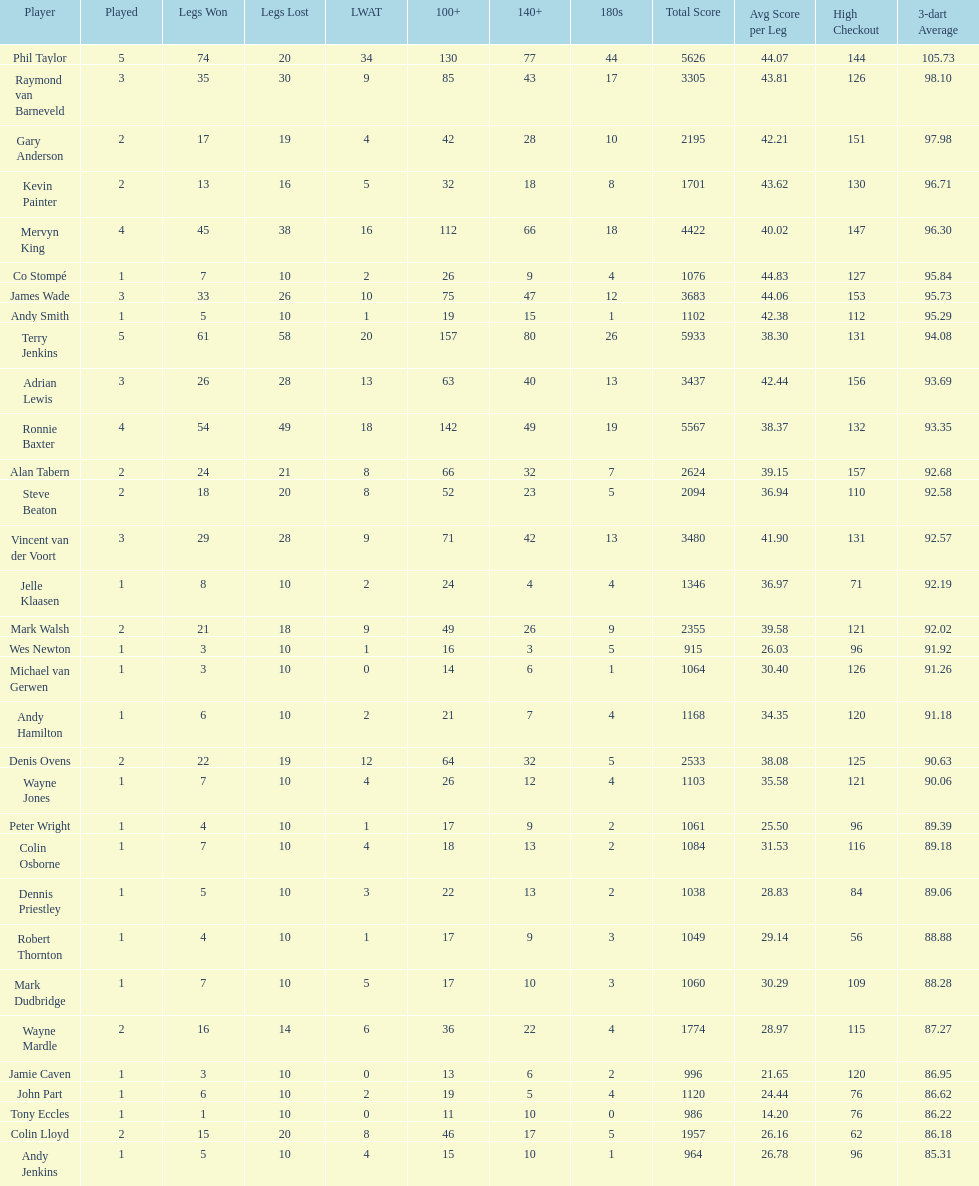How many players have a 3 dart average of more than 97? 3. 